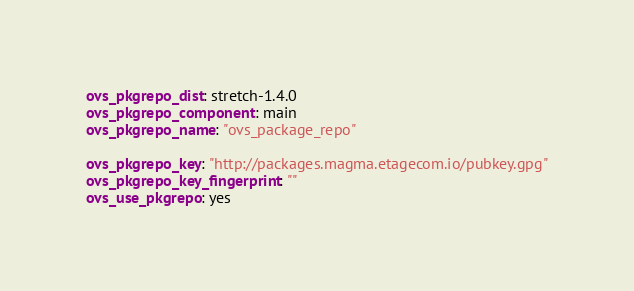Convert code to text. <code><loc_0><loc_0><loc_500><loc_500><_YAML_>ovs_pkgrepo_dist: stretch-1.4.0
ovs_pkgrepo_component: main
ovs_pkgrepo_name: "ovs_package_repo"

ovs_pkgrepo_key: "http://packages.magma.etagecom.io/pubkey.gpg"
ovs_pkgrepo_key_fingerprint: ""
ovs_use_pkgrepo: yes
</code> 